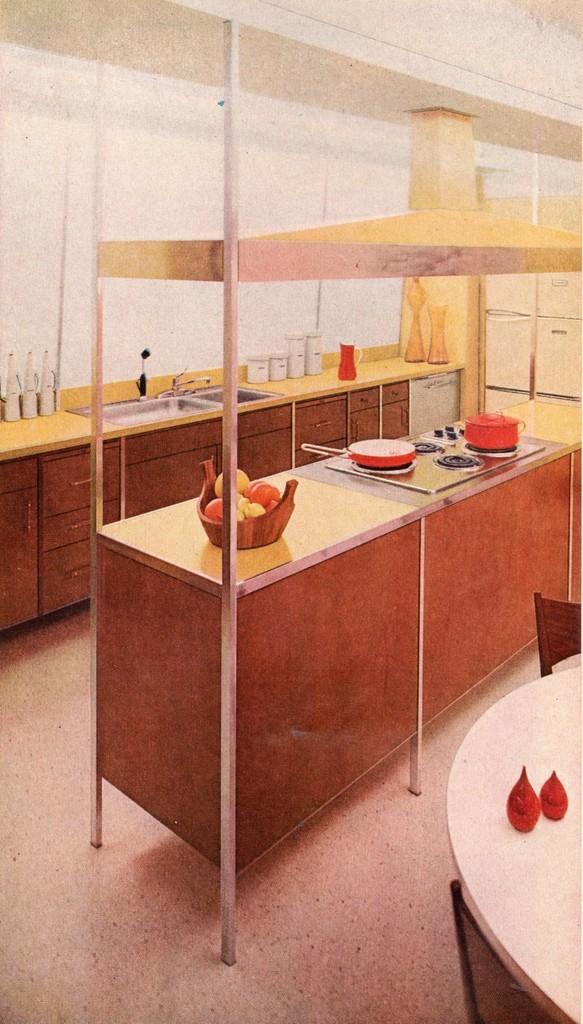How would you summarize this image in a sentence or two? In the image there is a kitchen and on the kitchen table there is a stove and on the stove there are some vessels, beside that there are some of fruits kept in a bowl and on the other table there is a wash basin, around that there are some bottles. On the right side there is a dining table and around the table there are two chairs. 